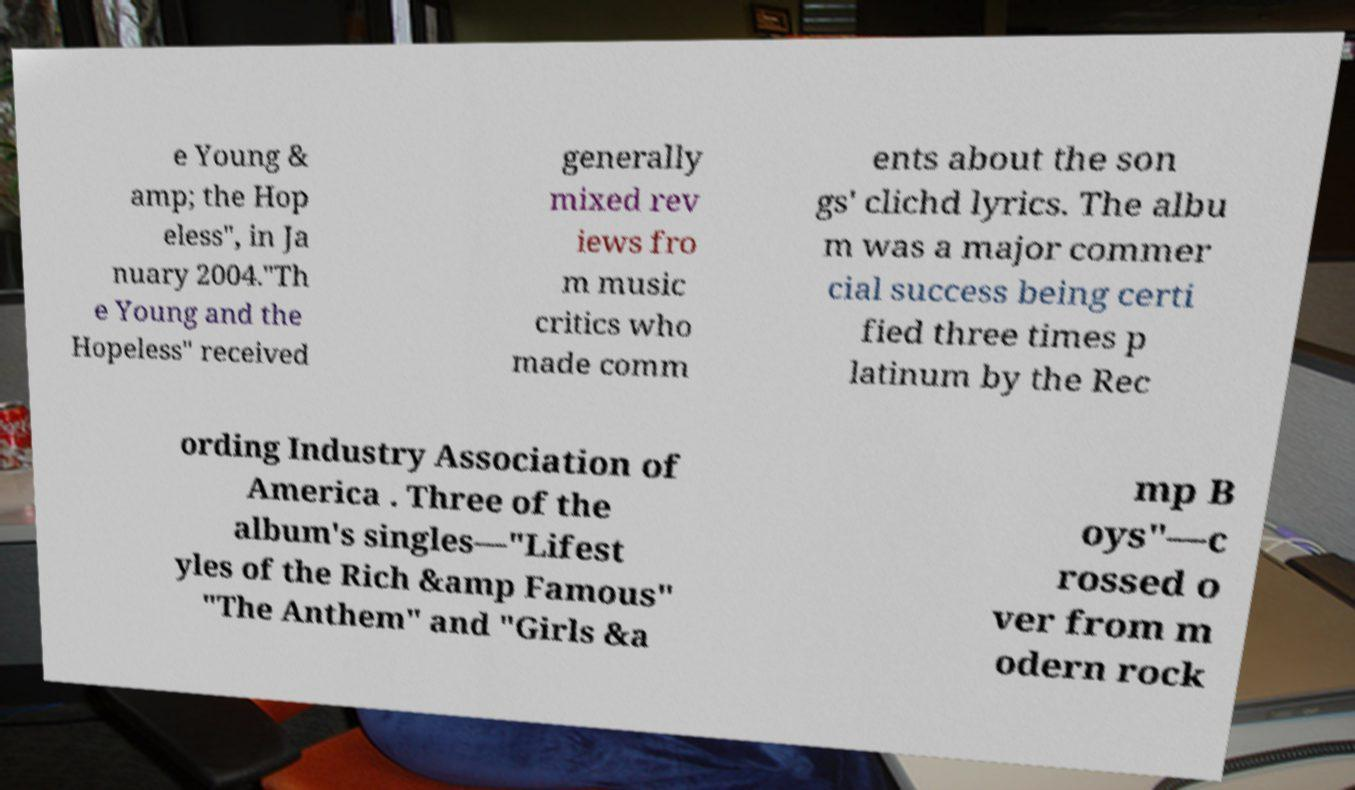Please read and relay the text visible in this image. What does it say? e Young & amp; the Hop eless", in Ja nuary 2004."Th e Young and the Hopeless" received generally mixed rev iews fro m music critics who made comm ents about the son gs' clichd lyrics. The albu m was a major commer cial success being certi fied three times p latinum by the Rec ording Industry Association of America . Three of the album's singles—"Lifest yles of the Rich &amp Famous" "The Anthem" and "Girls &a mp B oys"—c rossed o ver from m odern rock 